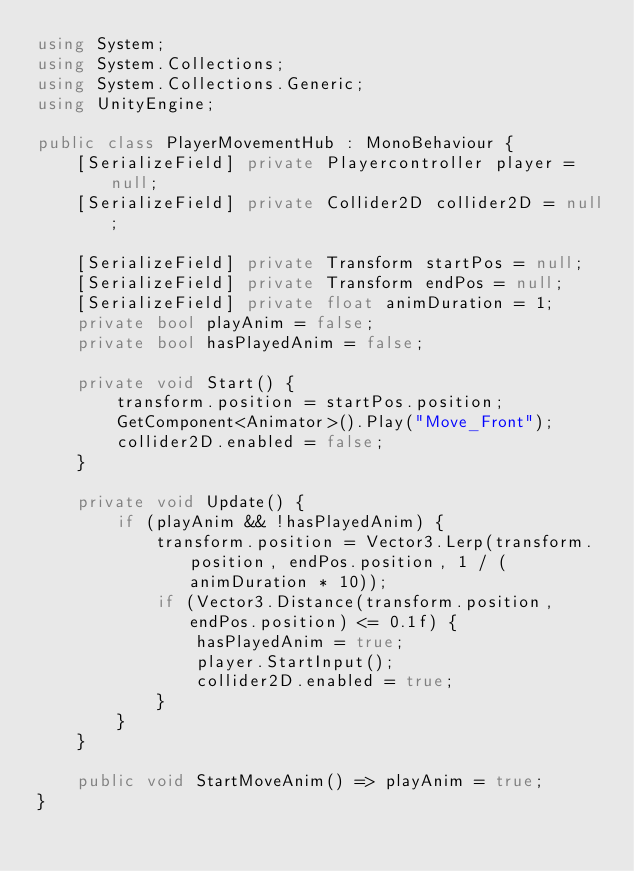<code> <loc_0><loc_0><loc_500><loc_500><_C#_>using System;
using System.Collections;
using System.Collections.Generic;
using UnityEngine;

public class PlayerMovementHub : MonoBehaviour {
    [SerializeField] private Playercontroller player = null;
    [SerializeField] private Collider2D collider2D = null;
    
    [SerializeField] private Transform startPos = null; 
    [SerializeField] private Transform endPos = null;
    [SerializeField] private float animDuration = 1;
    private bool playAnim = false;
    private bool hasPlayedAnim = false;
    
    private void Start() {
        transform.position = startPos.position;
        GetComponent<Animator>().Play("Move_Front");
        collider2D.enabled = false;
    }

    private void Update() {
        if (playAnim && !hasPlayedAnim) {
            transform.position = Vector3.Lerp(transform.position, endPos.position, 1 / (animDuration * 10));
            if (Vector3.Distance(transform.position, endPos.position) <= 0.1f) {
                hasPlayedAnim = true;
                player.StartInput();
                collider2D.enabled = true;
            }
        }
    }

    public void StartMoveAnim() => playAnim = true;
}
</code> 